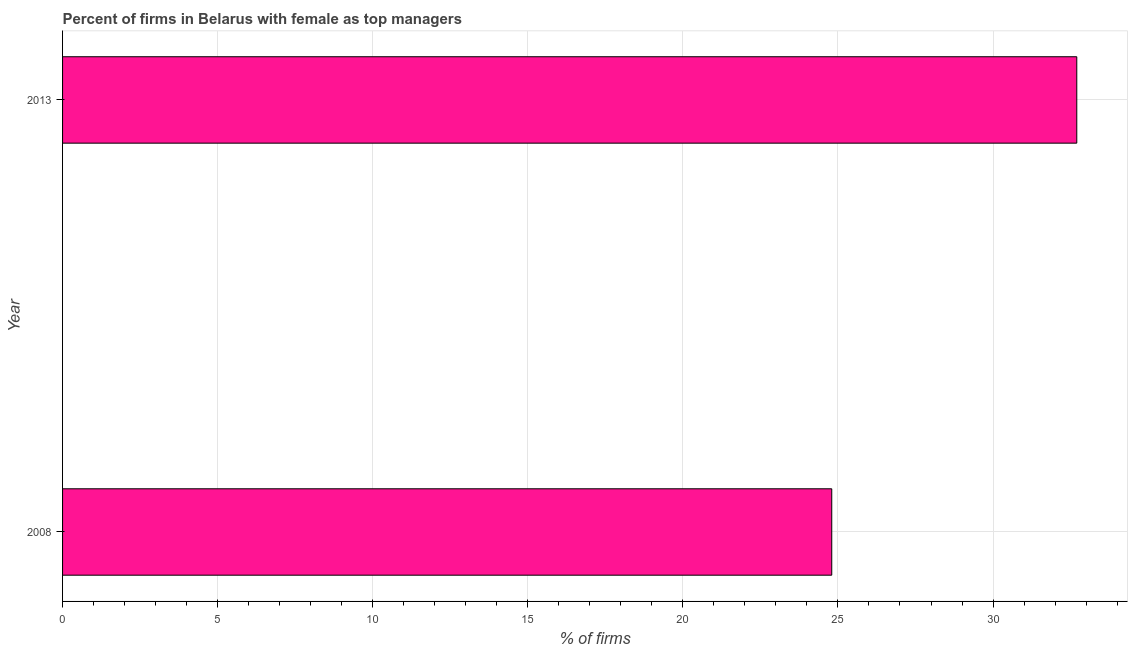Does the graph contain any zero values?
Offer a very short reply. No. Does the graph contain grids?
Provide a succinct answer. Yes. What is the title of the graph?
Make the answer very short. Percent of firms in Belarus with female as top managers. What is the label or title of the X-axis?
Offer a terse response. % of firms. What is the percentage of firms with female as top manager in 2013?
Ensure brevity in your answer.  32.7. Across all years, what is the maximum percentage of firms with female as top manager?
Offer a terse response. 32.7. Across all years, what is the minimum percentage of firms with female as top manager?
Ensure brevity in your answer.  24.8. In which year was the percentage of firms with female as top manager maximum?
Offer a very short reply. 2013. What is the sum of the percentage of firms with female as top manager?
Offer a very short reply. 57.5. What is the average percentage of firms with female as top manager per year?
Provide a short and direct response. 28.75. What is the median percentage of firms with female as top manager?
Your answer should be compact. 28.75. Do a majority of the years between 2008 and 2013 (inclusive) have percentage of firms with female as top manager greater than 23 %?
Provide a succinct answer. Yes. What is the ratio of the percentage of firms with female as top manager in 2008 to that in 2013?
Offer a terse response. 0.76. In how many years, is the percentage of firms with female as top manager greater than the average percentage of firms with female as top manager taken over all years?
Ensure brevity in your answer.  1. How many bars are there?
Make the answer very short. 2. Are all the bars in the graph horizontal?
Provide a short and direct response. Yes. How many years are there in the graph?
Keep it short and to the point. 2. What is the % of firms of 2008?
Your response must be concise. 24.8. What is the % of firms of 2013?
Offer a terse response. 32.7. What is the ratio of the % of firms in 2008 to that in 2013?
Your answer should be compact. 0.76. 